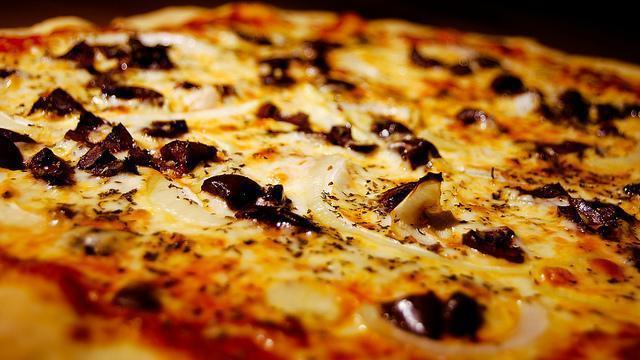How many pizzas are visible?
Give a very brief answer. 1. 